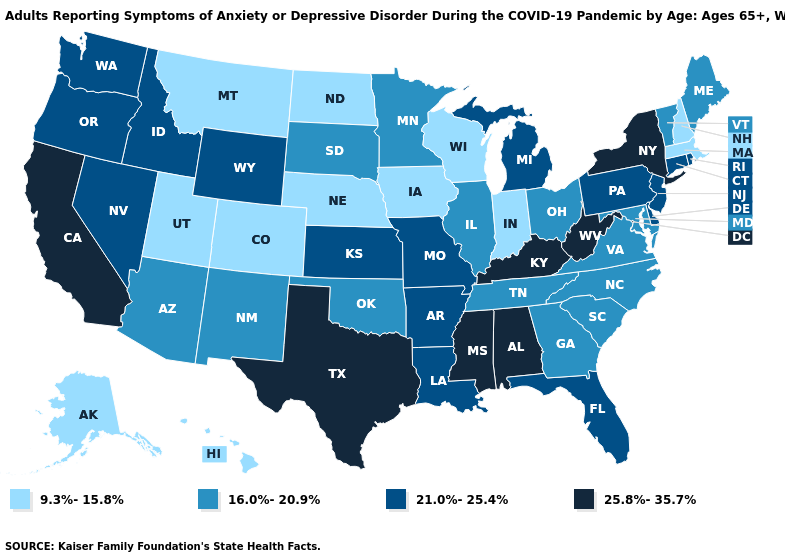Name the states that have a value in the range 16.0%-20.9%?
Keep it brief. Arizona, Georgia, Illinois, Maine, Maryland, Minnesota, New Mexico, North Carolina, Ohio, Oklahoma, South Carolina, South Dakota, Tennessee, Vermont, Virginia. Does Alabama have the highest value in the South?
Write a very short answer. Yes. What is the highest value in the USA?
Answer briefly. 25.8%-35.7%. What is the highest value in the USA?
Answer briefly. 25.8%-35.7%. Name the states that have a value in the range 16.0%-20.9%?
Quick response, please. Arizona, Georgia, Illinois, Maine, Maryland, Minnesota, New Mexico, North Carolina, Ohio, Oklahoma, South Carolina, South Dakota, Tennessee, Vermont, Virginia. Name the states that have a value in the range 25.8%-35.7%?
Keep it brief. Alabama, California, Kentucky, Mississippi, New York, Texas, West Virginia. What is the value of Arizona?
Short answer required. 16.0%-20.9%. What is the value of Florida?
Keep it brief. 21.0%-25.4%. Name the states that have a value in the range 9.3%-15.8%?
Be succinct. Alaska, Colorado, Hawaii, Indiana, Iowa, Massachusetts, Montana, Nebraska, New Hampshire, North Dakota, Utah, Wisconsin. Does the map have missing data?
Be succinct. No. What is the lowest value in the South?
Write a very short answer. 16.0%-20.9%. What is the value of Virginia?
Be succinct. 16.0%-20.9%. What is the value of New Mexico?
Be succinct. 16.0%-20.9%. Among the states that border New Mexico , does Oklahoma have the highest value?
Be succinct. No. Name the states that have a value in the range 9.3%-15.8%?
Short answer required. Alaska, Colorado, Hawaii, Indiana, Iowa, Massachusetts, Montana, Nebraska, New Hampshire, North Dakota, Utah, Wisconsin. 